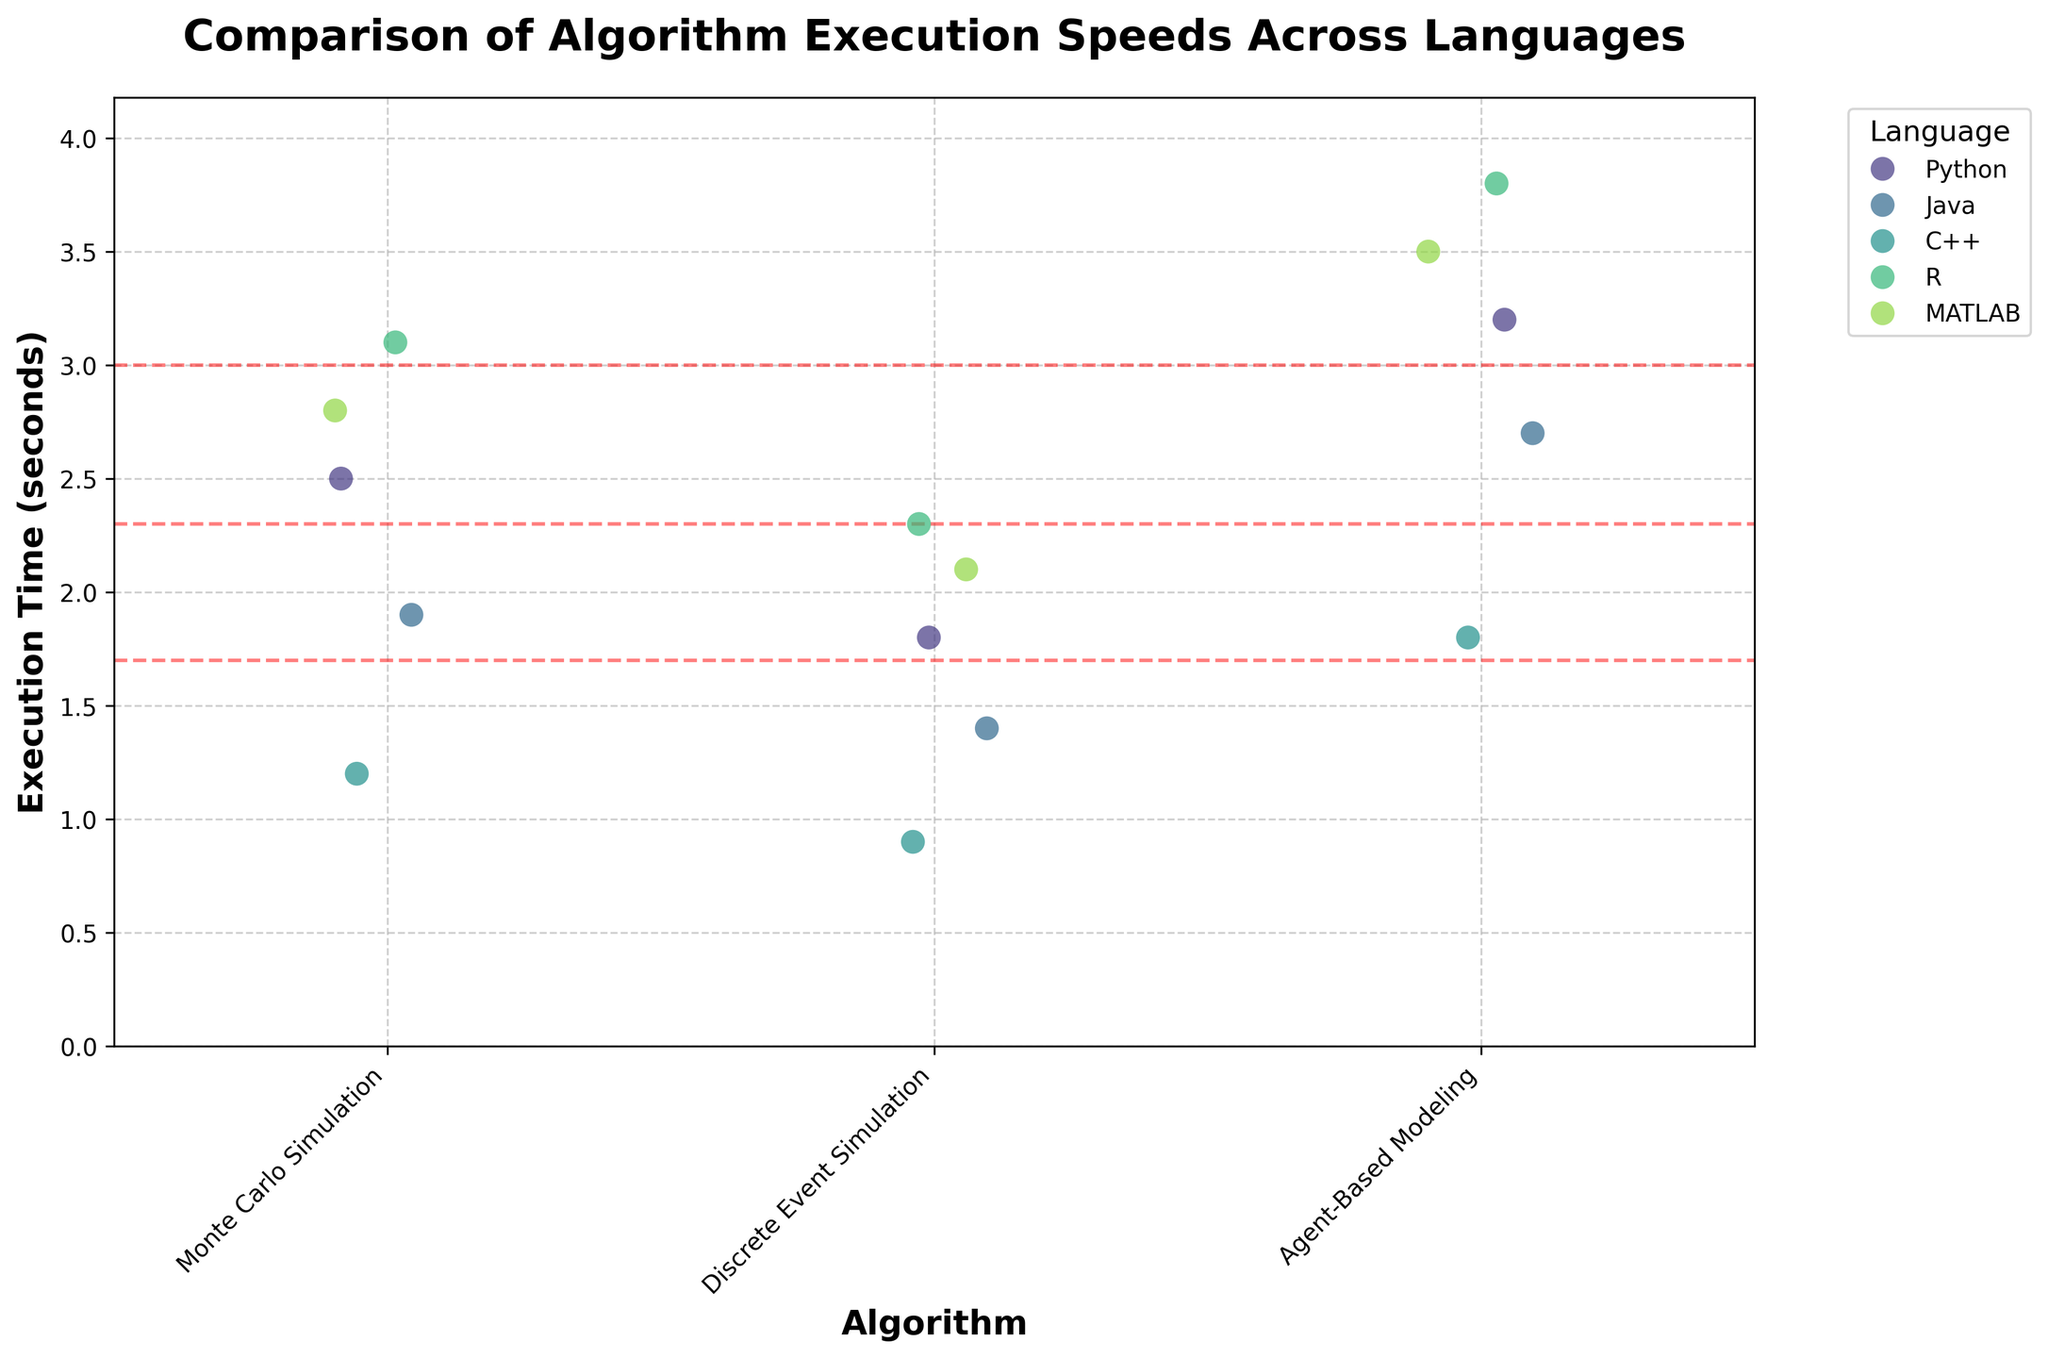What is the title of the strip plot? The title is usually bold and situated at the top of the figure. In this case, the title reads 'Comparison of Algorithm Execution Speeds Across Languages'.
Answer: Comparison of Algorithm Execution Speeds Across Languages Which algorithm has the longest average execution time? Examine the horizontal red dashed lines for each algorithm. The highest average line indicates the algorithm with the longest execution time. In this case, it's 'Agent-Based Modeling'.
Answer: Agent-Based Modeling How many different programming languages are shown in the figure? The legend on the right side lists all the languages used in the plot. Count the distinct languages listed in the legend. There are Python, Java, C++, R, and MATLAB.
Answer: 5 Which language has the shortest execution time for the Discrete Event Simulation algorithm? Look for the shortest data point in the strip corresponding to 'Discrete Event Simulation'. In this case, C++ has the shortest execution time.
Answer: C++ What is the range of execution times for the Monte Carlo Simulation in Python? Find the data points for 'Monte Carlo Simulation' specific to Python and identify the minimum and maximum values. Python has execution times ranging from 2.5 seconds.
Answer: 2.5 Which algorithm and language pair has the highest execution time? Look for the data point that is furthest from the x-axis. The point in 'Agent-Based Modeling' with 'R' has the highest execution time of 3.8 seconds.
Answer: Agent-Based Modeling in R On average, which language performs best across all algorithms? Look at the position of the red dashed lines. The lowest average lines across all algorithms belong to C++.
Answer: C++ How does the execution time of MATLAB for Agent-Based Modeling compare to Python for the same algorithm? Compare the data points for 'Agent-Based Modeling' between MATLAB and Python. MATLAB's execution time is 3.5 seconds, whereas Python's is 3.2 seconds.
Answer: MATLAB is slower What is the average execution time of Java for all the algorithms? Identify the Java data points for each algorithm, sum them up, and calculate the average. The times are 1.9 (Monte Carlo Simulation), 1.4 (Discrete Event Simulation), and 2.7 (Agent-Based Modeling). So, (1.9 + 1.4 + 2.7) / 3 = 2.0
Answer: 2.0 seconds Which algorithm has the most varied execution times across all languages? The spread of data points within each strip indicates variability. 'Agent-Based Modeling' has the widest spread of execution times.
Answer: Agent-Based Modeling 